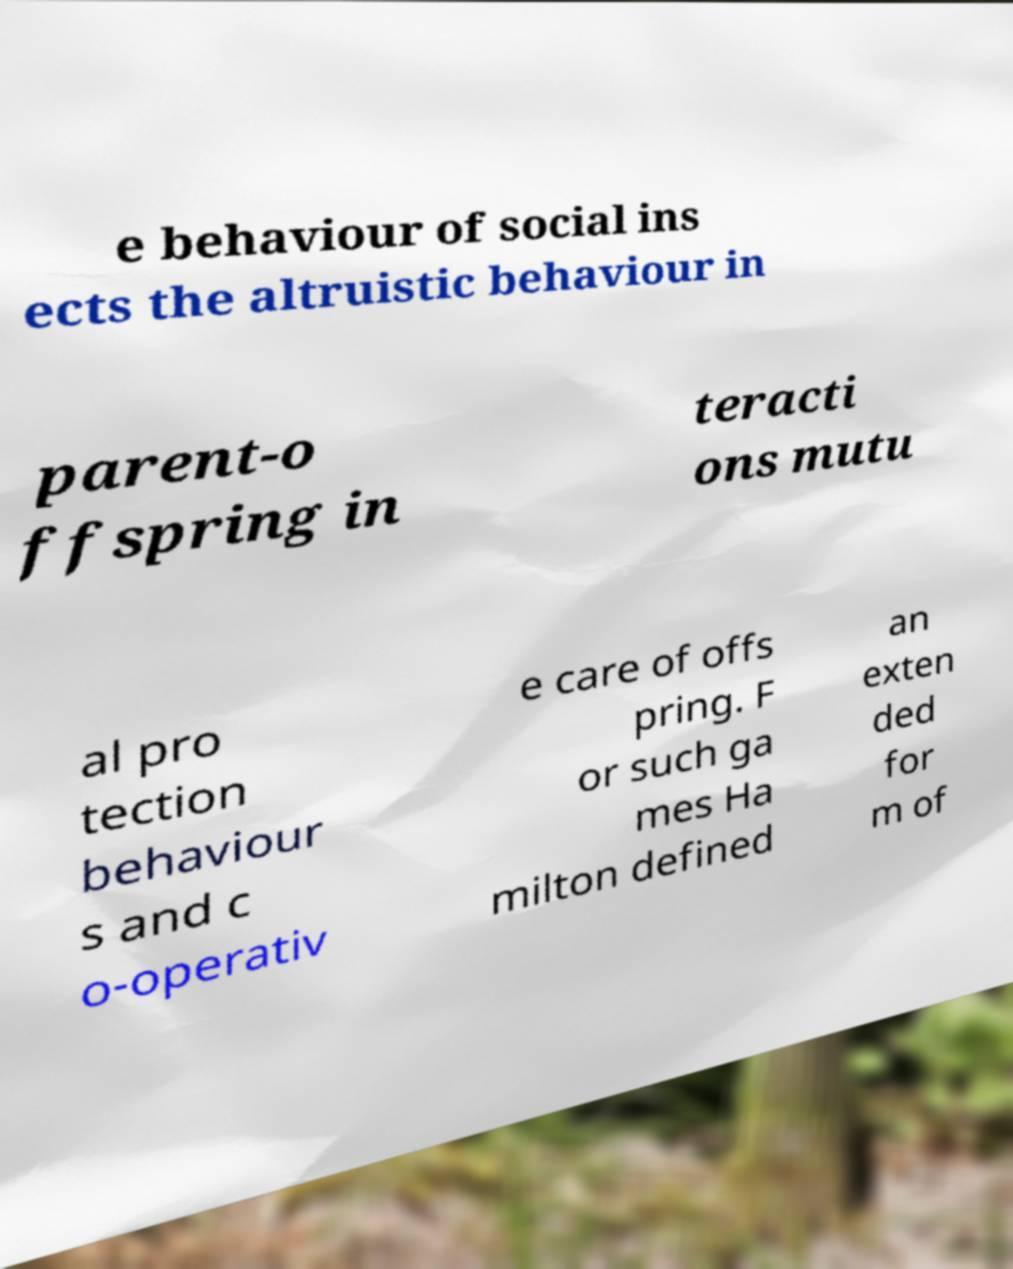I need the written content from this picture converted into text. Can you do that? e behaviour of social ins ects the altruistic behaviour in parent-o ffspring in teracti ons mutu al pro tection behaviour s and c o-operativ e care of offs pring. F or such ga mes Ha milton defined an exten ded for m of 